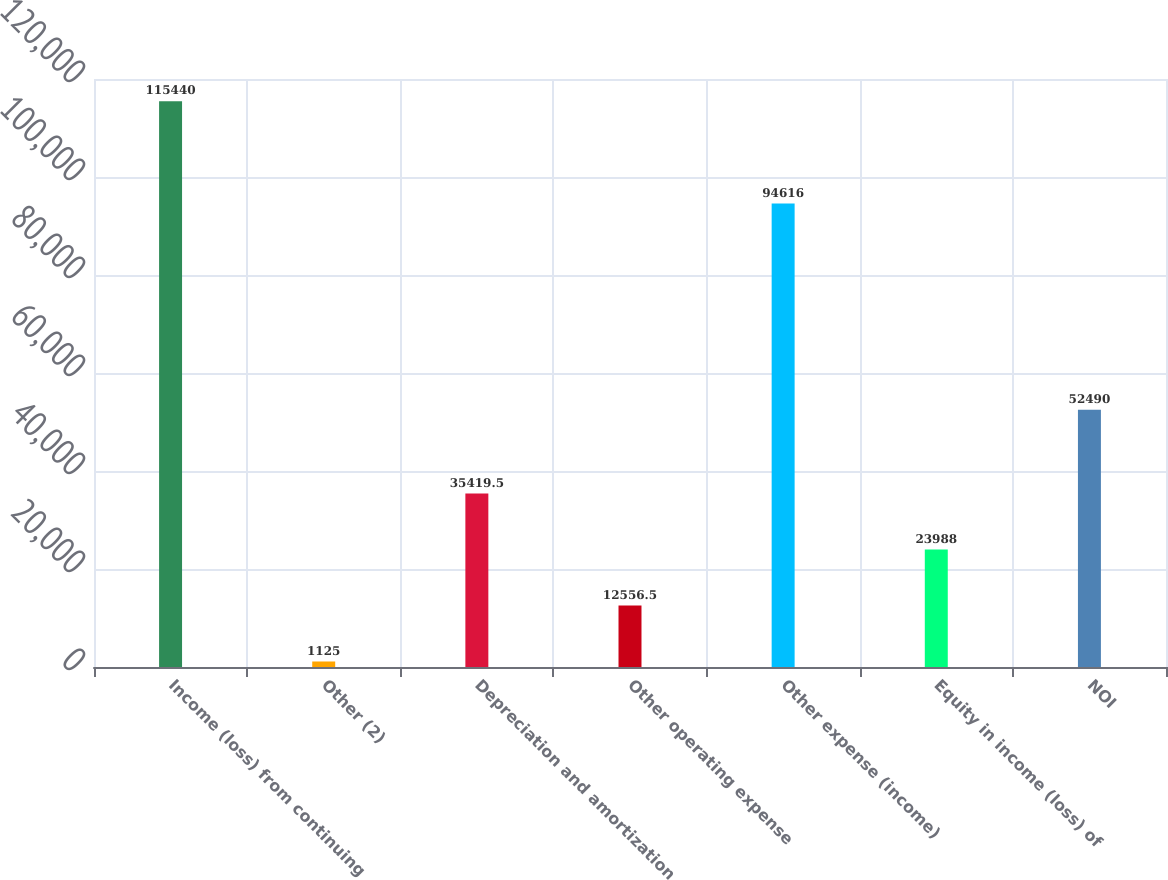Convert chart to OTSL. <chart><loc_0><loc_0><loc_500><loc_500><bar_chart><fcel>Income (loss) from continuing<fcel>Other (2)<fcel>Depreciation and amortization<fcel>Other operating expense<fcel>Other expense (income)<fcel>Equity in income (loss) of<fcel>NOI<nl><fcel>115440<fcel>1125<fcel>35419.5<fcel>12556.5<fcel>94616<fcel>23988<fcel>52490<nl></chart> 